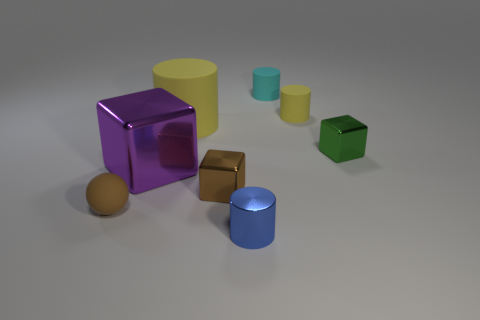Subtract 1 cylinders. How many cylinders are left? 3 Subtract all purple balls. Subtract all brown blocks. How many balls are left? 1 Add 1 small objects. How many objects exist? 9 Subtract all spheres. How many objects are left? 7 Add 8 small green blocks. How many small green blocks are left? 9 Add 3 small purple matte cylinders. How many small purple matte cylinders exist? 3 Subtract 1 purple cubes. How many objects are left? 7 Subtract all large cyan cylinders. Subtract all shiny objects. How many objects are left? 4 